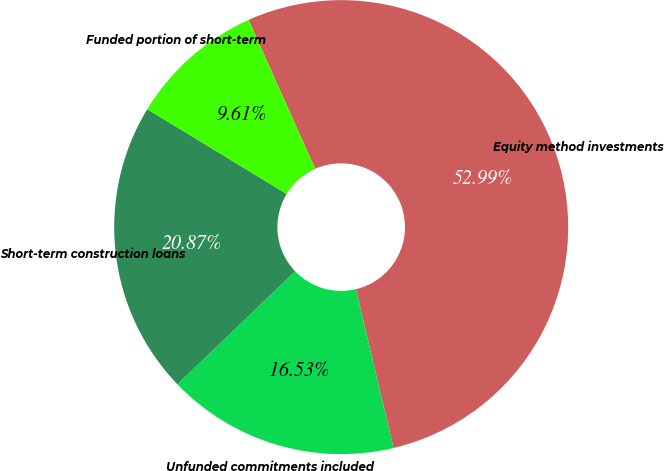Convert chart to OTSL. <chart><loc_0><loc_0><loc_500><loc_500><pie_chart><fcel>Equity method investments<fcel>Unfunded commitments included<fcel>Short-term construction loans<fcel>Funded portion of short-term<nl><fcel>52.99%<fcel>16.53%<fcel>20.87%<fcel>9.61%<nl></chart> 